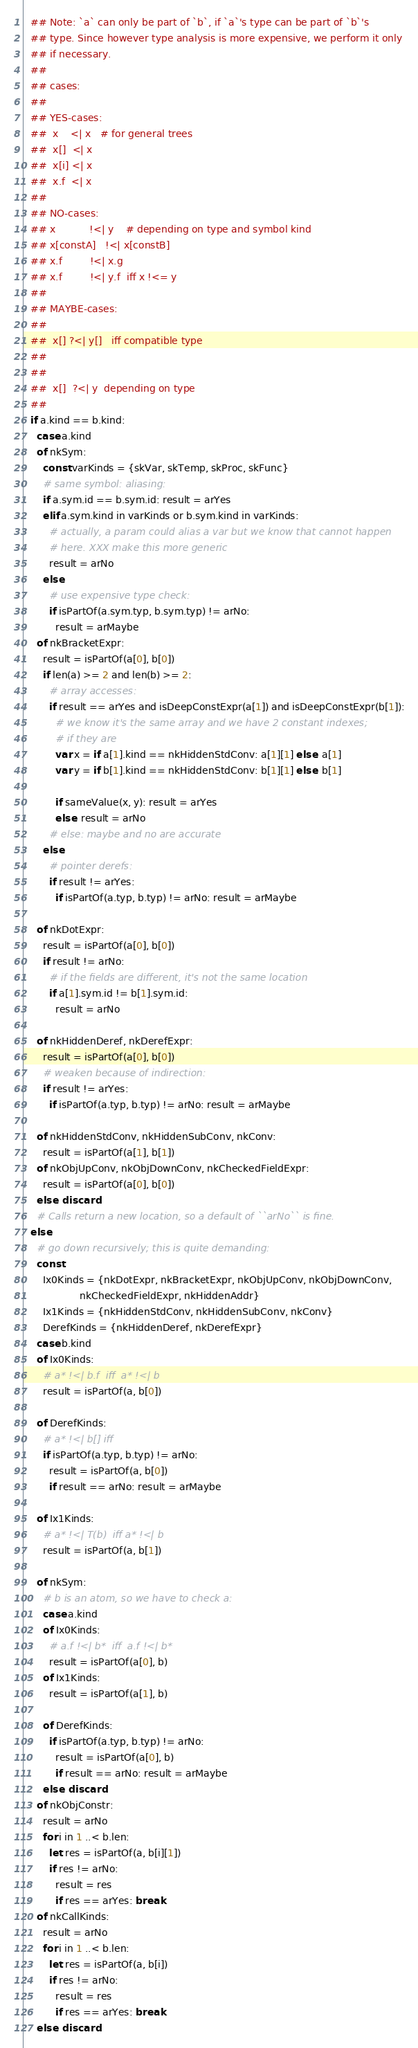Convert code to text. <code><loc_0><loc_0><loc_500><loc_500><_Nim_>  ## Note: `a` can only be part of `b`, if `a`'s type can be part of `b`'s
  ## type. Since however type analysis is more expensive, we perform it only
  ## if necessary.
  ##
  ## cases:
  ##
  ## YES-cases:
  ##  x    <| x   # for general trees
  ##  x[]  <| x
  ##  x[i] <| x
  ##  x.f  <| x
  ##
  ## NO-cases:
  ## x           !<| y    # depending on type and symbol kind
  ## x[constA]   !<| x[constB]
  ## x.f         !<| x.g
  ## x.f         !<| y.f  iff x !<= y
  ##
  ## MAYBE-cases:
  ##
  ##  x[] ?<| y[]   iff compatible type
  ##
  ##
  ##  x[]  ?<| y  depending on type
  ##
  if a.kind == b.kind:
    case a.kind
    of nkSym:
      const varKinds = {skVar, skTemp, skProc, skFunc}
      # same symbol: aliasing:
      if a.sym.id == b.sym.id: result = arYes
      elif a.sym.kind in varKinds or b.sym.kind in varKinds:
        # actually, a param could alias a var but we know that cannot happen
        # here. XXX make this more generic
        result = arNo
      else:
        # use expensive type check:
        if isPartOf(a.sym.typ, b.sym.typ) != arNo:
          result = arMaybe
    of nkBracketExpr:
      result = isPartOf(a[0], b[0])
      if len(a) >= 2 and len(b) >= 2:
        # array accesses:
        if result == arYes and isDeepConstExpr(a[1]) and isDeepConstExpr(b[1]):
          # we know it's the same array and we have 2 constant indexes;
          # if they are
          var x = if a[1].kind == nkHiddenStdConv: a[1][1] else: a[1]
          var y = if b[1].kind == nkHiddenStdConv: b[1][1] else: b[1]

          if sameValue(x, y): result = arYes
          else: result = arNo
        # else: maybe and no are accurate
      else:
        # pointer derefs:
        if result != arYes:
          if isPartOf(a.typ, b.typ) != arNo: result = arMaybe

    of nkDotExpr:
      result = isPartOf(a[0], b[0])
      if result != arNo:
        # if the fields are different, it's not the same location
        if a[1].sym.id != b[1].sym.id:
          result = arNo

    of nkHiddenDeref, nkDerefExpr:
      result = isPartOf(a[0], b[0])
      # weaken because of indirection:
      if result != arYes:
        if isPartOf(a.typ, b.typ) != arNo: result = arMaybe

    of nkHiddenStdConv, nkHiddenSubConv, nkConv:
      result = isPartOf(a[1], b[1])
    of nkObjUpConv, nkObjDownConv, nkCheckedFieldExpr:
      result = isPartOf(a[0], b[0])
    else: discard
    # Calls return a new location, so a default of ``arNo`` is fine.
  else:
    # go down recursively; this is quite demanding:
    const
      Ix0Kinds = {nkDotExpr, nkBracketExpr, nkObjUpConv, nkObjDownConv,
                  nkCheckedFieldExpr, nkHiddenAddr}
      Ix1Kinds = {nkHiddenStdConv, nkHiddenSubConv, nkConv}
      DerefKinds = {nkHiddenDeref, nkDerefExpr}
    case b.kind
    of Ix0Kinds:
      # a* !<| b.f  iff  a* !<| b
      result = isPartOf(a, b[0])

    of DerefKinds:
      # a* !<| b[] iff
      if isPartOf(a.typ, b.typ) != arNo:
        result = isPartOf(a, b[0])
        if result == arNo: result = arMaybe

    of Ix1Kinds:
      # a* !<| T(b)  iff a* !<| b
      result = isPartOf(a, b[1])

    of nkSym:
      # b is an atom, so we have to check a:
      case a.kind
      of Ix0Kinds:
        # a.f !<| b*  iff  a.f !<| b*
        result = isPartOf(a[0], b)
      of Ix1Kinds:
        result = isPartOf(a[1], b)

      of DerefKinds:
        if isPartOf(a.typ, b.typ) != arNo:
          result = isPartOf(a[0], b)
          if result == arNo: result = arMaybe
      else: discard
    of nkObjConstr:
      result = arNo
      for i in 1 ..< b.len:
        let res = isPartOf(a, b[i][1])
        if res != arNo:
          result = res
          if res == arYes: break
    of nkCallKinds:
      result = arNo
      for i in 1 ..< b.len:
        let res = isPartOf(a, b[i])
        if res != arNo:
          result = res
          if res == arYes: break
    else: discard
</code> 